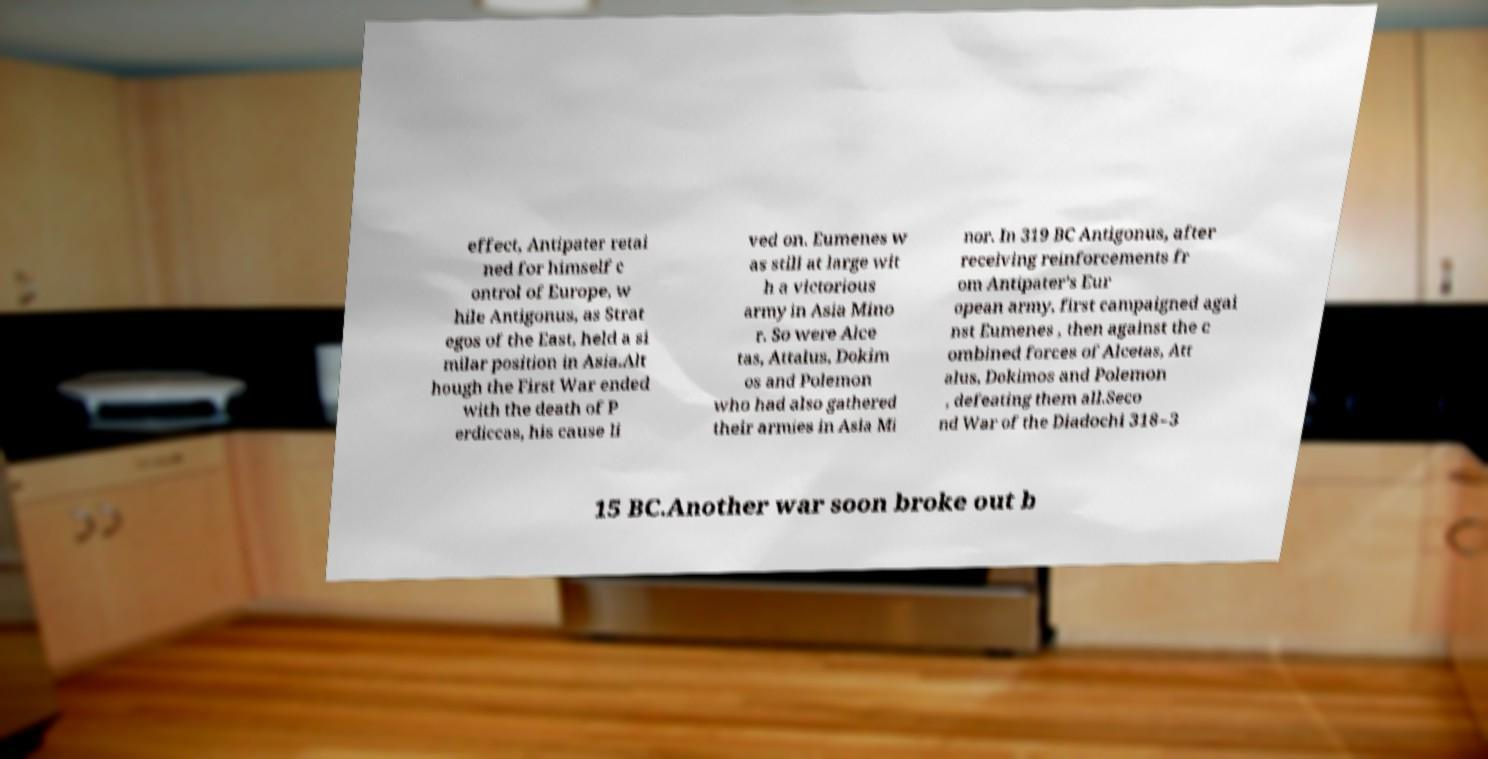Please identify and transcribe the text found in this image. effect, Antipater retai ned for himself c ontrol of Europe, w hile Antigonus, as Strat egos of the East, held a si milar position in Asia.Alt hough the First War ended with the death of P erdiccas, his cause li ved on. Eumenes w as still at large wit h a victorious army in Asia Mino r. So were Alce tas, Attalus, Dokim os and Polemon who had also gathered their armies in Asia Mi nor. In 319 BC Antigonus, after receiving reinforcements fr om Antipater's Eur opean army, first campaigned agai nst Eumenes , then against the c ombined forces of Alcetas, Att alus, Dokimos and Polemon , defeating them all.Seco nd War of the Diadochi 318–3 15 BC.Another war soon broke out b 